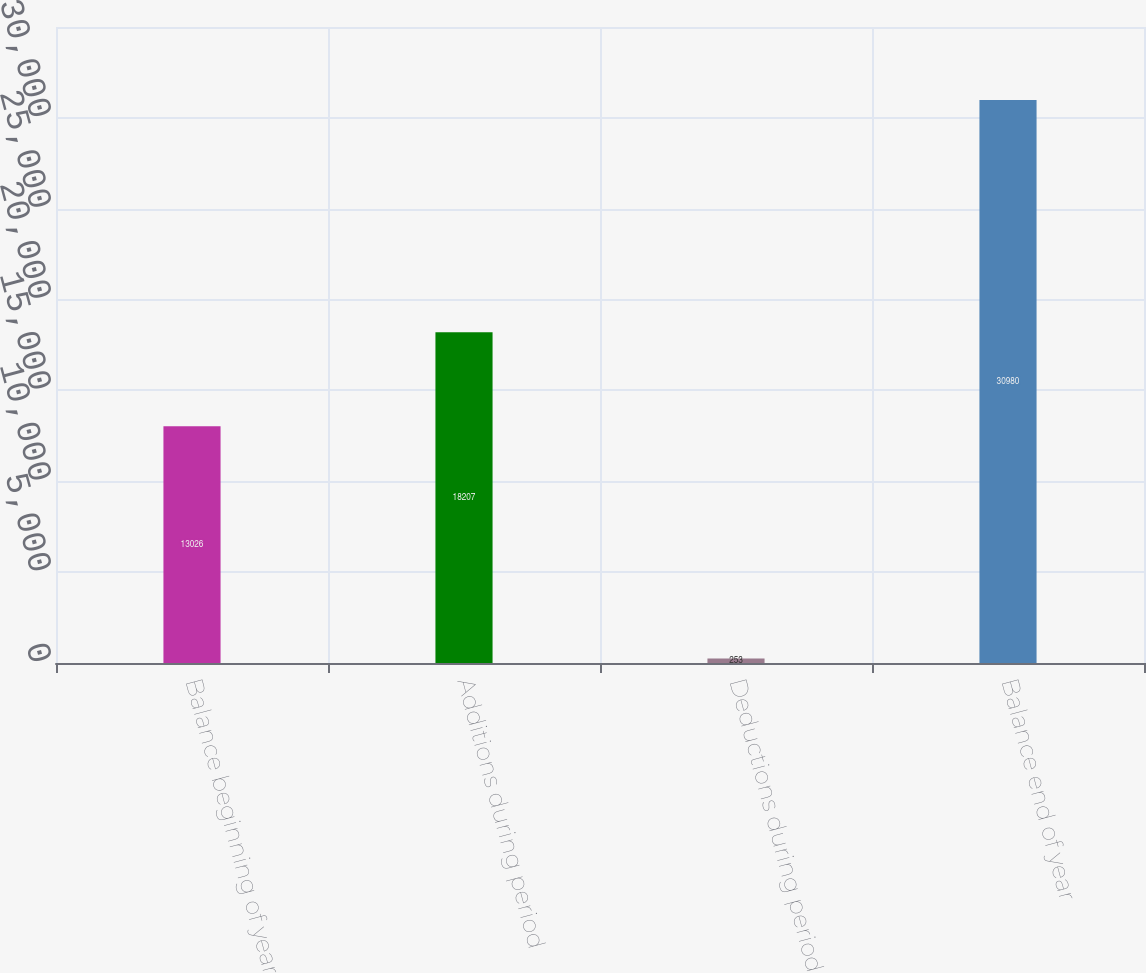Convert chart to OTSL. <chart><loc_0><loc_0><loc_500><loc_500><bar_chart><fcel>Balance beginning of year<fcel>Additions during period<fcel>Deductions during period<fcel>Balance end of year<nl><fcel>13026<fcel>18207<fcel>253<fcel>30980<nl></chart> 